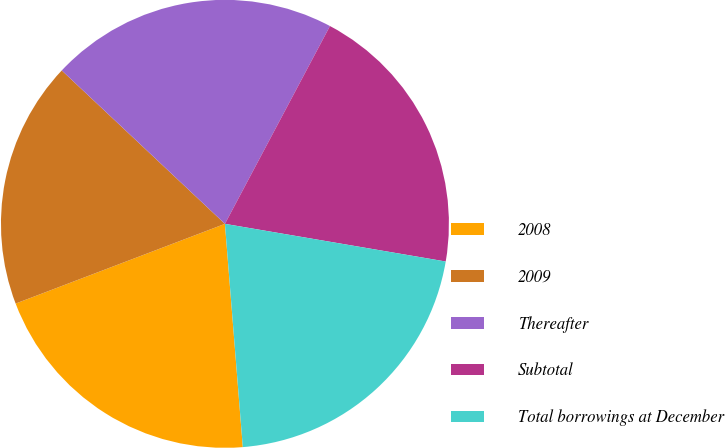Convert chart. <chart><loc_0><loc_0><loc_500><loc_500><pie_chart><fcel>2008<fcel>2009<fcel>Thereafter<fcel>Subtotal<fcel>Total borrowings at December<nl><fcel>20.48%<fcel>17.8%<fcel>20.76%<fcel>19.92%<fcel>21.04%<nl></chart> 